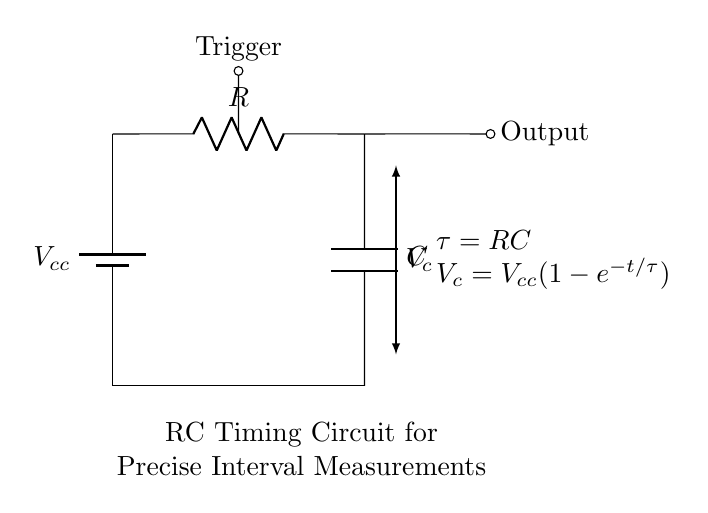What is the voltage source in this circuit? The voltage source is labeled as Vcc, which is the input voltage supplied to the circuit.
Answer: Vcc What is the value of the capacitor labeled in the diagram? The diagram does not specify a numerical value for the capacitor, it is simply labeled as C.
Answer: C What is the time constant for this RC circuit? The time constant is given by the formula tau equals RC, indicating the relationship between resistance and capacitance that affects the charge and discharge times.
Answer: tau equals RC What is the output of this RC timing circuit? The output is taken from the point where the capacitor connects to the load, indicated by a short and is labeled as Output.
Answer: Output What does Vc represent in this circuit? Vc represents the voltage across the capacitor at any given time, which can vary as the capacitor charges or discharges.
Answer: Vc What happens to Vc over time according to the formula? According to the formula, Vc increases exponentially towards Vcc as time progresses, reflecting the charging behavior of the capacitor.
Answer: Increases exponentially How does the resistor affect the circuit operation? The resistor value R determines the time constant tau, influencing how quickly the capacitor charges or discharges, thus affecting the interval measurement.
Answer: Influences charge time 